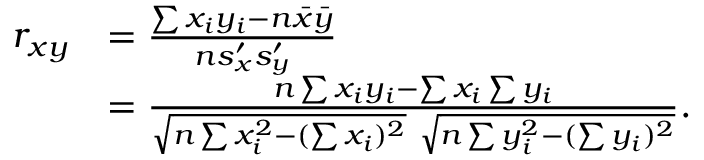<formula> <loc_0><loc_0><loc_500><loc_500>{ \begin{array} { r l } { r _ { x y } } & { = { \frac { \sum x _ { i } y _ { i } - n { \bar { x } } { \bar { y } } } { n s _ { x } ^ { \prime } s _ { y } ^ { \prime } } } } \\ & { = { \frac { n \sum x _ { i } y _ { i } - \sum x _ { i } \sum y _ { i } } { { \sqrt { n \sum x _ { i } ^ { 2 } - ( \sum x _ { i } ) ^ { 2 } } } { \sqrt { n \sum y _ { i } ^ { 2 } - ( \sum y _ { i } ) ^ { 2 } } } } } . } \end{array} }</formula> 